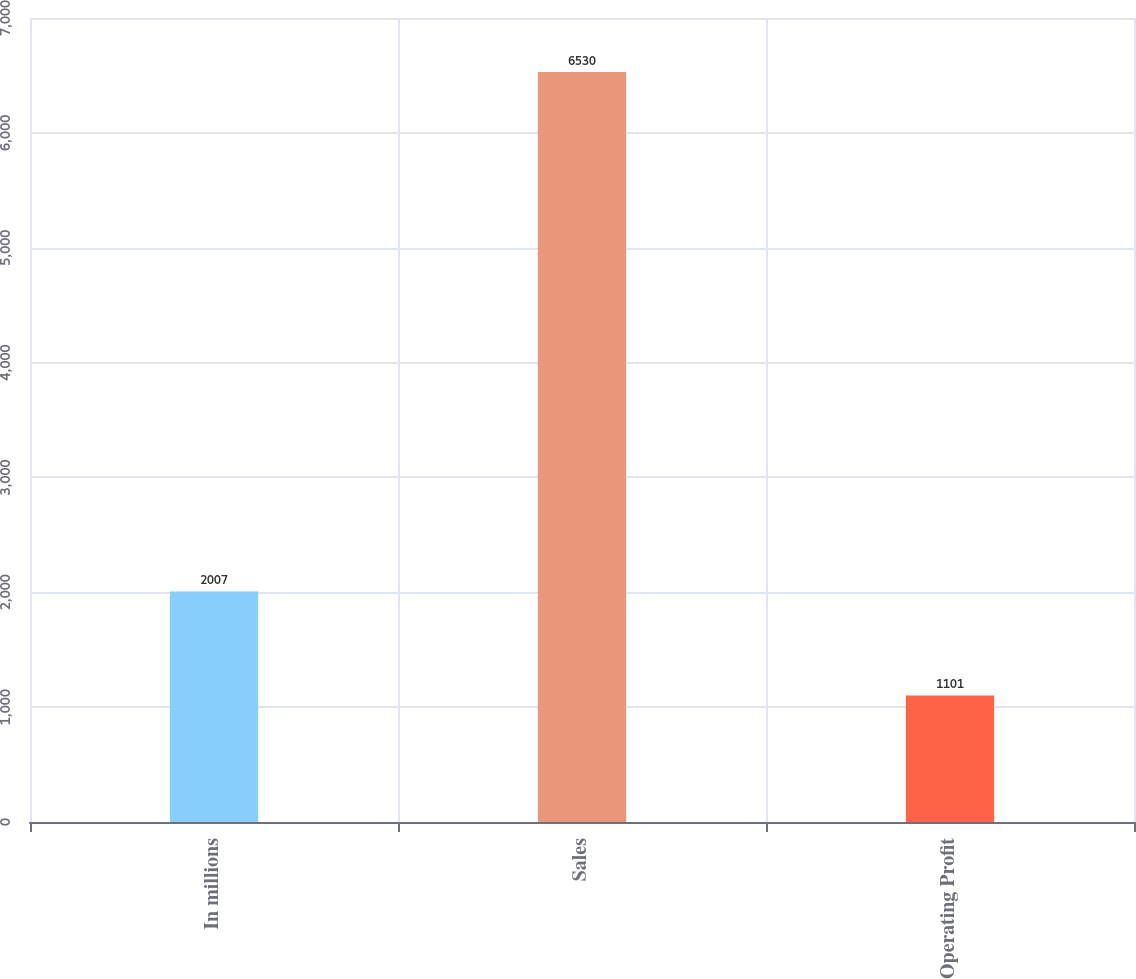Convert chart. <chart><loc_0><loc_0><loc_500><loc_500><bar_chart><fcel>In millions<fcel>Sales<fcel>Operating Profit<nl><fcel>2007<fcel>6530<fcel>1101<nl></chart> 